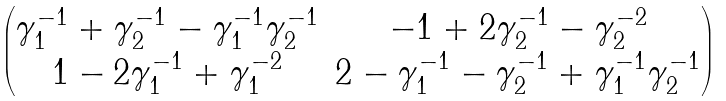<formula> <loc_0><loc_0><loc_500><loc_500>\begin{pmatrix} \gamma _ { 1 } ^ { - 1 } + \gamma _ { 2 } ^ { - 1 } - \gamma _ { 1 } ^ { - 1 } \gamma _ { 2 } ^ { - 1 } & - 1 + 2 \gamma _ { 2 } ^ { - 1 } - \gamma _ { 2 } ^ { - 2 } \\ 1 - 2 \gamma _ { 1 } ^ { - 1 } + \gamma _ { 1 } ^ { - 2 } & 2 - \gamma _ { 1 } ^ { - 1 } - \gamma _ { 2 } ^ { - 1 } + \gamma _ { 1 } ^ { - 1 } \gamma _ { 2 } ^ { - 1 } \end{pmatrix}</formula> 